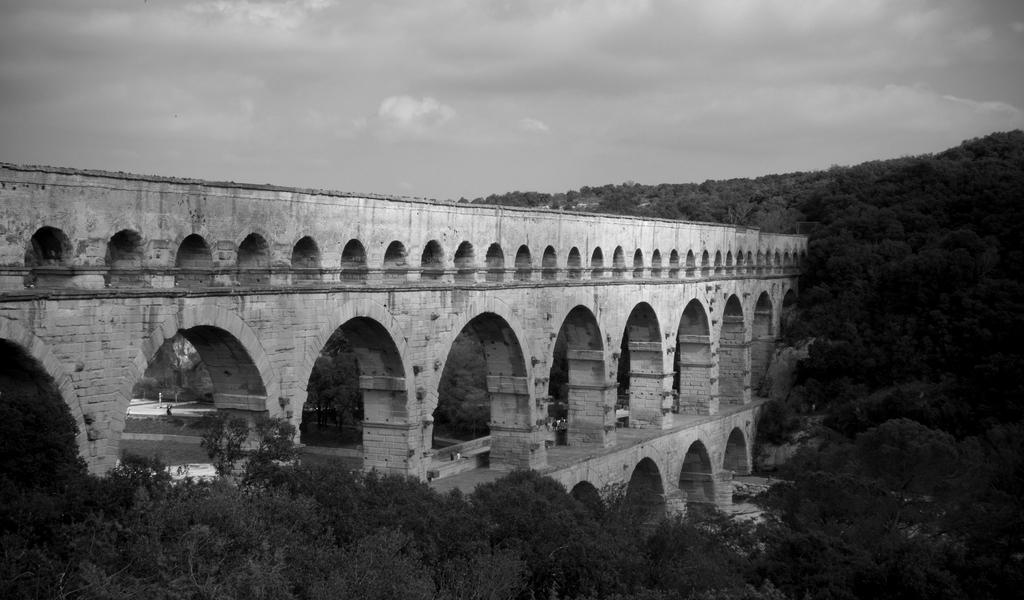In one or two sentences, can you explain what this image depicts? In this black and white image, we can see some trees. There is a bridge in the middle of the image. There is a hill on the right side of the image. There is a sky at the top of the image. 